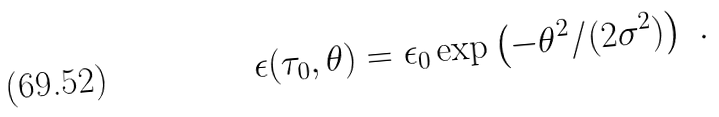Convert formula to latex. <formula><loc_0><loc_0><loc_500><loc_500>\epsilon ( \tau _ { 0 } , \theta ) = \epsilon _ { 0 } \exp \left ( - \theta ^ { 2 } / ( 2 \sigma ^ { 2 } ) \right ) \ .</formula> 